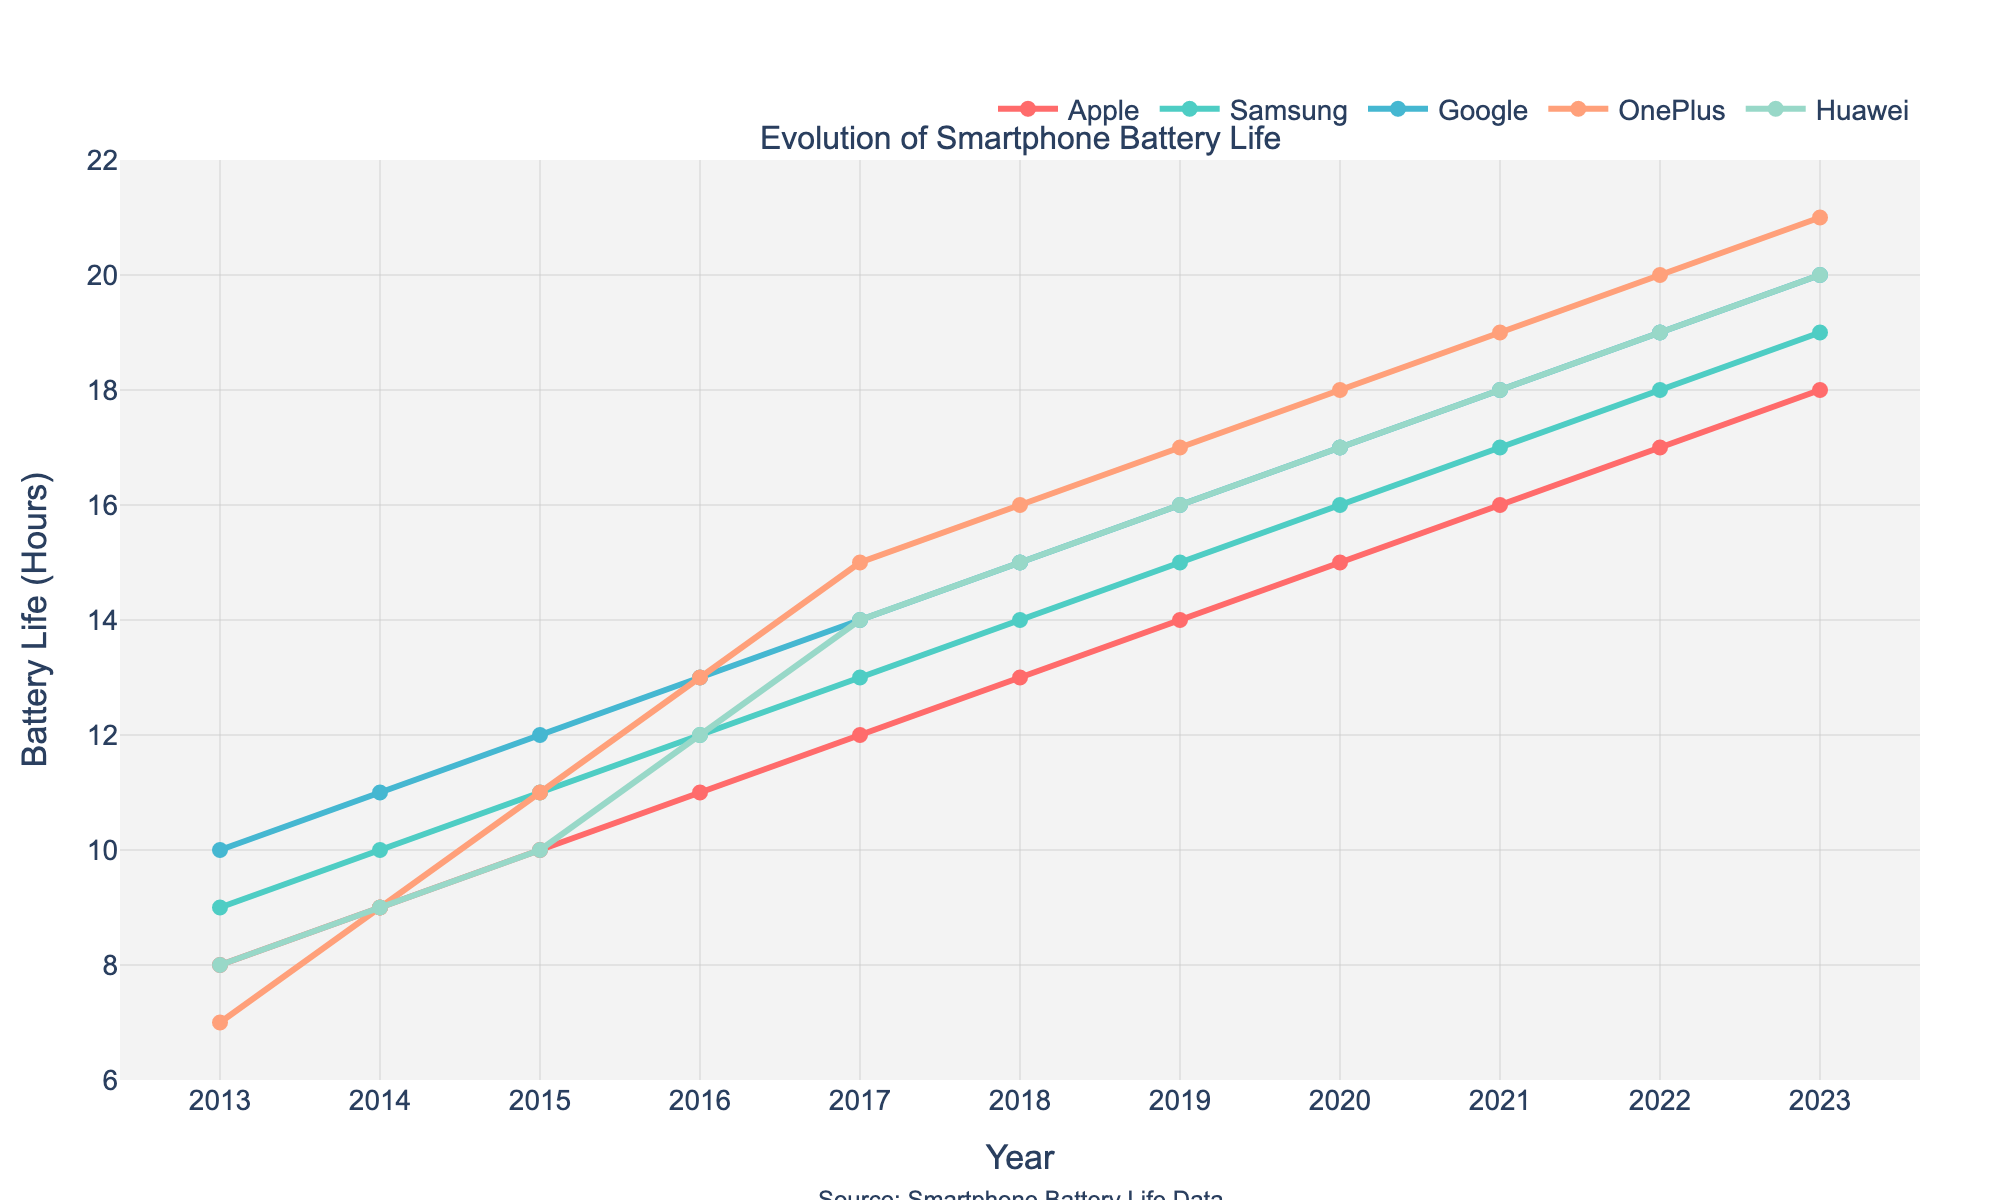Which brand showed the most improvement in battery life from 2013 to 2023? To find the most improvement, subtract the initial battery life in 2013 from the final battery life in 2023 for each brand. The differences are: Apple (18-8=10), Samsung (19-9=10), Google (20-10=10), OnePlus (21-7=14), Huawei (20-8=12). OnePlus shows the most improvement with an increase of 14 hours.
Answer: OnePlus Which year did Google surpass the 15-hour battery life mark? Look at the line corresponding to Google and identify the year when its battery life first exceeds 15 hours. According to the chart, Google first exceeds 15 hours in 2018.
Answer: 2018 Between Apple and Samsung, which brand had a better battery life in 2017 and by how much? Compare the battery life between Apple and Samsung in 2017. Apple has 12 hours, while Samsung has 13 hours in 2017. The difference is 13 - 12 = 1 hour, with Samsung having the better battery life.
Answer: Samsung by 1 hour What is the average battery life across all brands in 2022? Sum the battery lives of all brands in 2022 and divide by the number of brands. (17 + 18 + 19 + 20 + 19) / 5 = 93 / 5 = 18.6 hours.
Answer: 18.6 hours Which brand consistently increased its battery life every year without any drop from 2013 to 2023? Look at the lines of each brand to see if the battery life steadily increases each year without dropping. Apple, Samsung, Google, OnePlus, and Huawei all follow this pattern. Therefore, all listed brands consistently increased their battery life every year.
Answer: Apple, Samsung, Google, OnePlus, Huawei What was the difference in battery life between Google and Huawei in the year 2015? Find the battery life for Google and Huawei in 2015. Google's battery life was 12 hours, and Huawei's was 10 hours. The difference is 12 - 10 = 2 hours.
Answer: 2 hours In which year did OnePlus first surpass Apple in battery life? Compare the battery life of OnePlus and Apple year by year to determine when OnePlus first exceeds Apple's battery life. This happens in 2017 when OnePlus has 15 hours and Apple has 12 hours.
Answer: 2017 How many brands had a battery life of at least 19 hours in 2023? Look at the battery life of each brand in 2023 and count the number with 19 hours or more. The brands are Samsung (19), Google (20), OnePlus (21), and Huawei (20), making a total of 4 brands.
Answer: 4 brands Among the five brands, which had the smallest battery life improvement over the decade? Calculate the battery life improvement from 2013 to 2023 for each brand. Apple (18-8=10), Samsung (19-9=10), Google (20-10=10), OnePlus (21-7=14), Huawei (20-8=12). The smallest improvement is shared by Apple, Samsung, and Google with an increase of 10 hours each.
Answer: Apple, Samsung, Google 